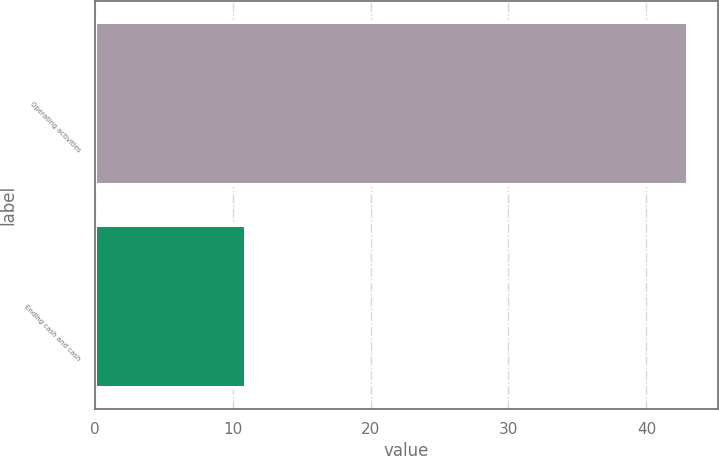Convert chart to OTSL. <chart><loc_0><loc_0><loc_500><loc_500><bar_chart><fcel>Operating activities<fcel>Ending cash and cash<nl><fcel>43<fcel>11<nl></chart> 